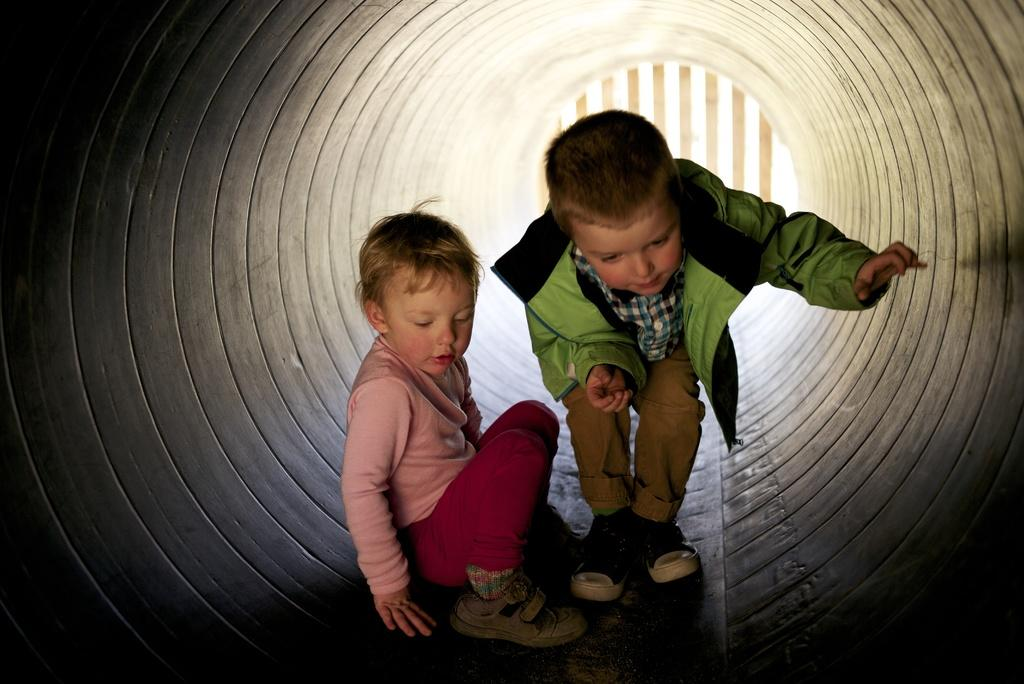How many children are present in the image? There are two children in the image. Where are the children located? The children are inside a tunnel. What type of structure can be seen in the image? There are wooden poles visible in the image. What type of religion is being practiced by the children in the image? There is no indication of any religious practice in the image; it simply shows two children inside a tunnel with wooden poles. 